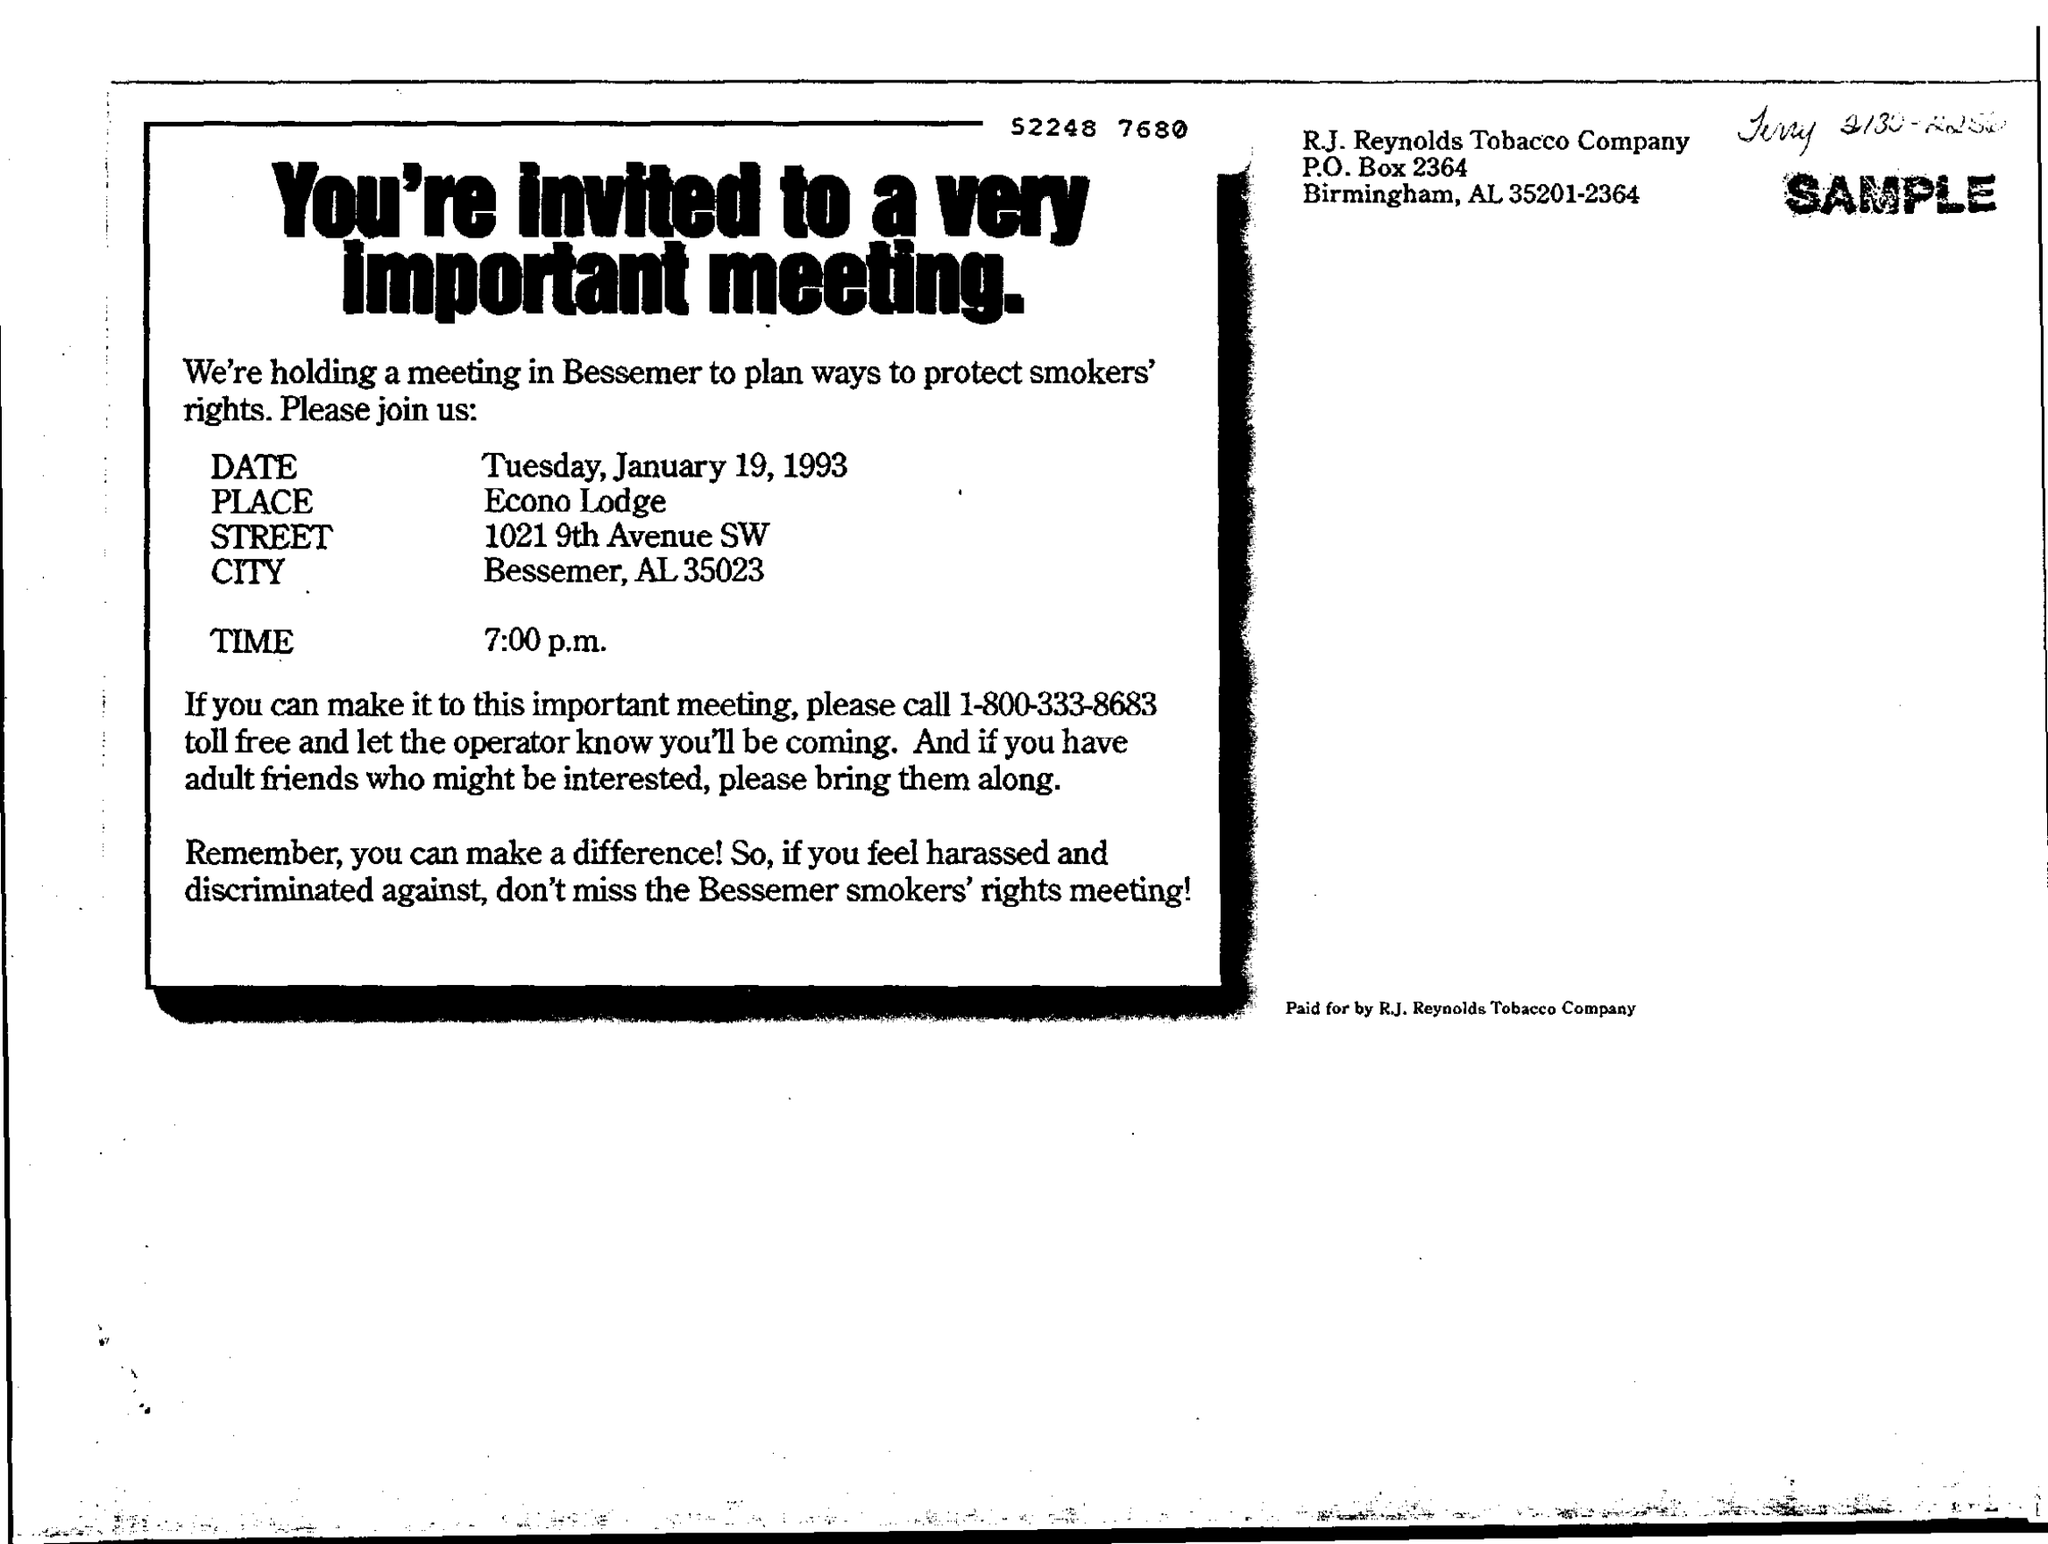Give some essential details in this illustration. The meeting was held on Tuesday, January 19, 1993. The purpose of this meeting is being held in Bessemer to devise strategies for safeguarding the rights of smokers. The meeting is held in Bessemer, Alabama, specifically in the location of 35023. This invitation is from the R.J. Reynolds Tobacco Company. The meeting is held at 7:00 p.m. 